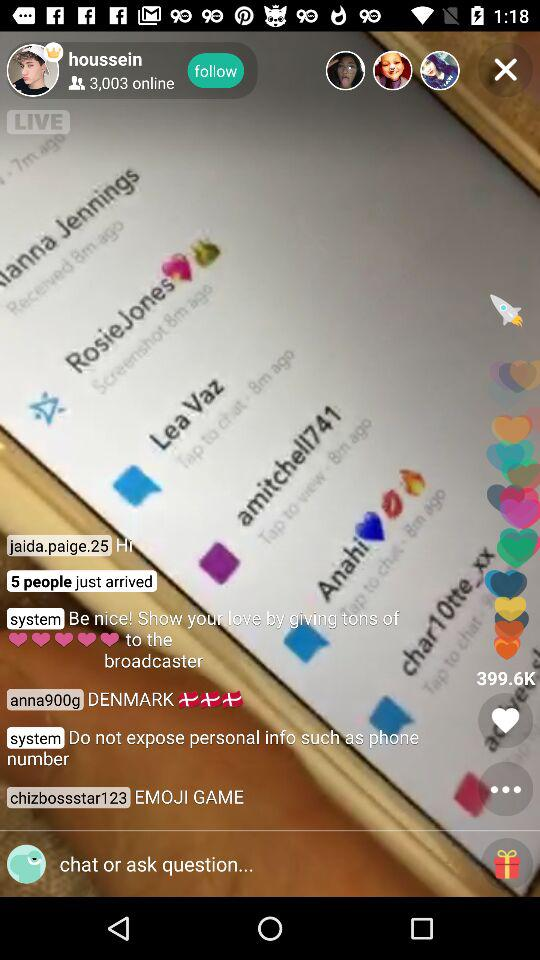How many people liked the live video? The live video was liked by 399.6K people. 